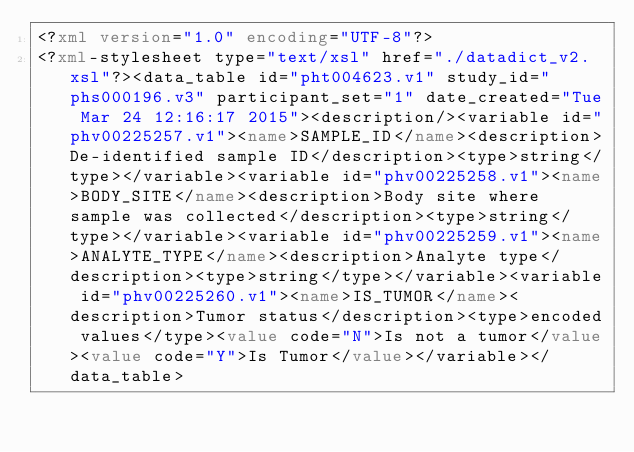Convert code to text. <code><loc_0><loc_0><loc_500><loc_500><_XML_><?xml version="1.0" encoding="UTF-8"?>
<?xml-stylesheet type="text/xsl" href="./datadict_v2.xsl"?><data_table id="pht004623.v1" study_id="phs000196.v3" participant_set="1" date_created="Tue Mar 24 12:16:17 2015"><description/><variable id="phv00225257.v1"><name>SAMPLE_ID</name><description>De-identified sample ID</description><type>string</type></variable><variable id="phv00225258.v1"><name>BODY_SITE</name><description>Body site where sample was collected</description><type>string</type></variable><variable id="phv00225259.v1"><name>ANALYTE_TYPE</name><description>Analyte type</description><type>string</type></variable><variable id="phv00225260.v1"><name>IS_TUMOR</name><description>Tumor status</description><type>encoded values</type><value code="N">Is not a tumor</value><value code="Y">Is Tumor</value></variable></data_table>
</code> 